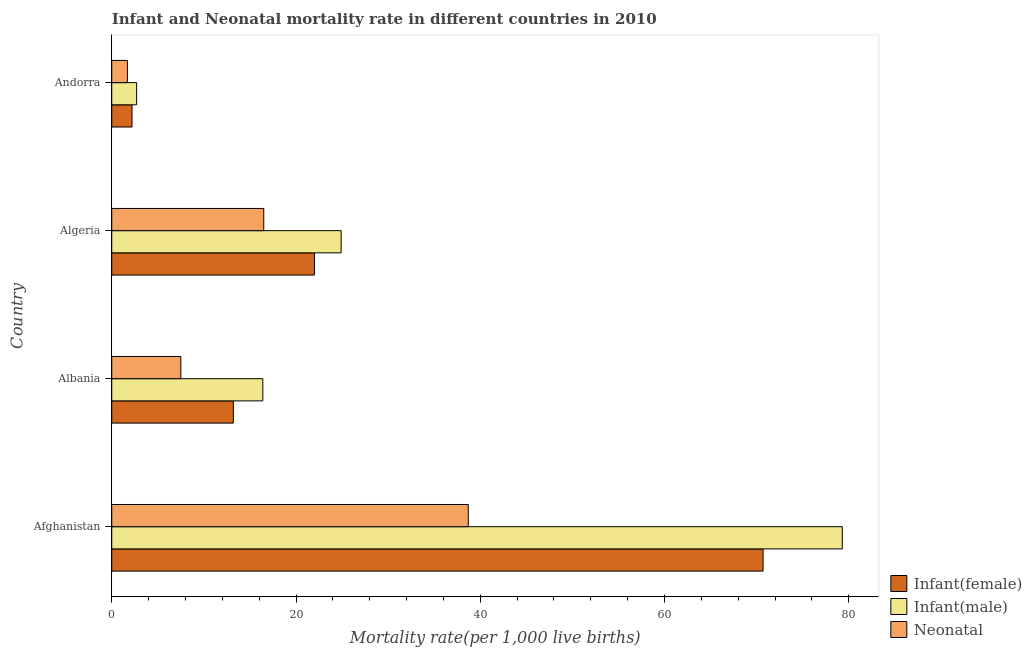How many different coloured bars are there?
Your response must be concise. 3. How many groups of bars are there?
Your answer should be compact. 4. Are the number of bars per tick equal to the number of legend labels?
Make the answer very short. Yes. Are the number of bars on each tick of the Y-axis equal?
Give a very brief answer. Yes. How many bars are there on the 4th tick from the bottom?
Give a very brief answer. 3. What is the label of the 1st group of bars from the top?
Ensure brevity in your answer.  Andorra. In how many cases, is the number of bars for a given country not equal to the number of legend labels?
Make the answer very short. 0. Across all countries, what is the maximum infant mortality rate(female)?
Provide a short and direct response. 70.7. In which country was the infant mortality rate(male) maximum?
Your response must be concise. Afghanistan. In which country was the infant mortality rate(male) minimum?
Keep it short and to the point. Andorra. What is the total infant mortality rate(male) in the graph?
Your response must be concise. 123.3. What is the difference between the infant mortality rate(female) in Afghanistan and that in Algeria?
Your answer should be compact. 48.7. What is the difference between the infant mortality rate(male) in Albania and the neonatal mortality rate in Algeria?
Give a very brief answer. -0.1. What is the average infant mortality rate(male) per country?
Offer a very short reply. 30.82. In how many countries, is the neonatal mortality rate greater than 68 ?
Your answer should be very brief. 0. What is the ratio of the infant mortality rate(male) in Albania to that in Algeria?
Give a very brief answer. 0.66. Is the infant mortality rate(female) in Afghanistan less than that in Andorra?
Offer a terse response. No. What is the difference between the highest and the second highest infant mortality rate(male)?
Make the answer very short. 54.4. What is the difference between the highest and the lowest infant mortality rate(male)?
Offer a very short reply. 76.6. What does the 3rd bar from the top in Albania represents?
Your answer should be compact. Infant(female). What does the 2nd bar from the bottom in Afghanistan represents?
Make the answer very short. Infant(male). How many bars are there?
Your response must be concise. 12. How many countries are there in the graph?
Offer a terse response. 4. What is the difference between two consecutive major ticks on the X-axis?
Provide a short and direct response. 20. Where does the legend appear in the graph?
Your answer should be very brief. Bottom right. How are the legend labels stacked?
Your answer should be compact. Vertical. What is the title of the graph?
Ensure brevity in your answer.  Infant and Neonatal mortality rate in different countries in 2010. What is the label or title of the X-axis?
Provide a succinct answer. Mortality rate(per 1,0 live births). What is the label or title of the Y-axis?
Make the answer very short. Country. What is the Mortality rate(per 1,000 live births) of Infant(female) in Afghanistan?
Provide a short and direct response. 70.7. What is the Mortality rate(per 1,000 live births) in Infant(male) in Afghanistan?
Ensure brevity in your answer.  79.3. What is the Mortality rate(per 1,000 live births) of Neonatal  in Afghanistan?
Your answer should be very brief. 38.7. What is the Mortality rate(per 1,000 live births) of Infant(female) in Algeria?
Offer a very short reply. 22. What is the Mortality rate(per 1,000 live births) in Infant(male) in Algeria?
Make the answer very short. 24.9. What is the Mortality rate(per 1,000 live births) in Infant(male) in Andorra?
Provide a succinct answer. 2.7. What is the Mortality rate(per 1,000 live births) in Neonatal  in Andorra?
Provide a succinct answer. 1.7. Across all countries, what is the maximum Mortality rate(per 1,000 live births) of Infant(female)?
Provide a succinct answer. 70.7. Across all countries, what is the maximum Mortality rate(per 1,000 live births) of Infant(male)?
Make the answer very short. 79.3. Across all countries, what is the maximum Mortality rate(per 1,000 live births) in Neonatal ?
Keep it short and to the point. 38.7. Across all countries, what is the minimum Mortality rate(per 1,000 live births) of Infant(female)?
Your response must be concise. 2.2. What is the total Mortality rate(per 1,000 live births) in Infant(female) in the graph?
Offer a terse response. 108.1. What is the total Mortality rate(per 1,000 live births) in Infant(male) in the graph?
Your response must be concise. 123.3. What is the total Mortality rate(per 1,000 live births) of Neonatal  in the graph?
Provide a short and direct response. 64.4. What is the difference between the Mortality rate(per 1,000 live births) in Infant(female) in Afghanistan and that in Albania?
Keep it short and to the point. 57.5. What is the difference between the Mortality rate(per 1,000 live births) in Infant(male) in Afghanistan and that in Albania?
Your response must be concise. 62.9. What is the difference between the Mortality rate(per 1,000 live births) of Neonatal  in Afghanistan and that in Albania?
Ensure brevity in your answer.  31.2. What is the difference between the Mortality rate(per 1,000 live births) in Infant(female) in Afghanistan and that in Algeria?
Ensure brevity in your answer.  48.7. What is the difference between the Mortality rate(per 1,000 live births) in Infant(male) in Afghanistan and that in Algeria?
Provide a short and direct response. 54.4. What is the difference between the Mortality rate(per 1,000 live births) of Neonatal  in Afghanistan and that in Algeria?
Provide a succinct answer. 22.2. What is the difference between the Mortality rate(per 1,000 live births) of Infant(female) in Afghanistan and that in Andorra?
Your answer should be very brief. 68.5. What is the difference between the Mortality rate(per 1,000 live births) of Infant(male) in Afghanistan and that in Andorra?
Give a very brief answer. 76.6. What is the difference between the Mortality rate(per 1,000 live births) of Neonatal  in Afghanistan and that in Andorra?
Give a very brief answer. 37. What is the difference between the Mortality rate(per 1,000 live births) in Infant(female) in Albania and that in Algeria?
Your response must be concise. -8.8. What is the difference between the Mortality rate(per 1,000 live births) of Infant(female) in Albania and that in Andorra?
Make the answer very short. 11. What is the difference between the Mortality rate(per 1,000 live births) of Infant(male) in Albania and that in Andorra?
Make the answer very short. 13.7. What is the difference between the Mortality rate(per 1,000 live births) of Neonatal  in Albania and that in Andorra?
Offer a very short reply. 5.8. What is the difference between the Mortality rate(per 1,000 live births) in Infant(female) in Algeria and that in Andorra?
Provide a succinct answer. 19.8. What is the difference between the Mortality rate(per 1,000 live births) in Infant(female) in Afghanistan and the Mortality rate(per 1,000 live births) in Infant(male) in Albania?
Your answer should be compact. 54.3. What is the difference between the Mortality rate(per 1,000 live births) of Infant(female) in Afghanistan and the Mortality rate(per 1,000 live births) of Neonatal  in Albania?
Your answer should be compact. 63.2. What is the difference between the Mortality rate(per 1,000 live births) in Infant(male) in Afghanistan and the Mortality rate(per 1,000 live births) in Neonatal  in Albania?
Provide a succinct answer. 71.8. What is the difference between the Mortality rate(per 1,000 live births) of Infant(female) in Afghanistan and the Mortality rate(per 1,000 live births) of Infant(male) in Algeria?
Your answer should be very brief. 45.8. What is the difference between the Mortality rate(per 1,000 live births) in Infant(female) in Afghanistan and the Mortality rate(per 1,000 live births) in Neonatal  in Algeria?
Your answer should be very brief. 54.2. What is the difference between the Mortality rate(per 1,000 live births) in Infant(male) in Afghanistan and the Mortality rate(per 1,000 live births) in Neonatal  in Algeria?
Your response must be concise. 62.8. What is the difference between the Mortality rate(per 1,000 live births) in Infant(female) in Afghanistan and the Mortality rate(per 1,000 live births) in Infant(male) in Andorra?
Ensure brevity in your answer.  68. What is the difference between the Mortality rate(per 1,000 live births) in Infant(male) in Afghanistan and the Mortality rate(per 1,000 live births) in Neonatal  in Andorra?
Offer a very short reply. 77.6. What is the difference between the Mortality rate(per 1,000 live births) in Infant(female) in Albania and the Mortality rate(per 1,000 live births) in Neonatal  in Algeria?
Your answer should be compact. -3.3. What is the difference between the Mortality rate(per 1,000 live births) of Infant(male) in Albania and the Mortality rate(per 1,000 live births) of Neonatal  in Algeria?
Ensure brevity in your answer.  -0.1. What is the difference between the Mortality rate(per 1,000 live births) in Infant(female) in Albania and the Mortality rate(per 1,000 live births) in Infant(male) in Andorra?
Your answer should be compact. 10.5. What is the difference between the Mortality rate(per 1,000 live births) in Infant(male) in Albania and the Mortality rate(per 1,000 live births) in Neonatal  in Andorra?
Ensure brevity in your answer.  14.7. What is the difference between the Mortality rate(per 1,000 live births) of Infant(female) in Algeria and the Mortality rate(per 1,000 live births) of Infant(male) in Andorra?
Your answer should be very brief. 19.3. What is the difference between the Mortality rate(per 1,000 live births) of Infant(female) in Algeria and the Mortality rate(per 1,000 live births) of Neonatal  in Andorra?
Provide a short and direct response. 20.3. What is the difference between the Mortality rate(per 1,000 live births) in Infant(male) in Algeria and the Mortality rate(per 1,000 live births) in Neonatal  in Andorra?
Your response must be concise. 23.2. What is the average Mortality rate(per 1,000 live births) of Infant(female) per country?
Provide a succinct answer. 27.02. What is the average Mortality rate(per 1,000 live births) of Infant(male) per country?
Offer a very short reply. 30.82. What is the average Mortality rate(per 1,000 live births) of Neonatal  per country?
Your answer should be very brief. 16.1. What is the difference between the Mortality rate(per 1,000 live births) of Infant(female) and Mortality rate(per 1,000 live births) of Infant(male) in Afghanistan?
Provide a succinct answer. -8.6. What is the difference between the Mortality rate(per 1,000 live births) in Infant(female) and Mortality rate(per 1,000 live births) in Neonatal  in Afghanistan?
Offer a very short reply. 32. What is the difference between the Mortality rate(per 1,000 live births) of Infant(male) and Mortality rate(per 1,000 live births) of Neonatal  in Afghanistan?
Provide a short and direct response. 40.6. What is the difference between the Mortality rate(per 1,000 live births) in Infant(male) and Mortality rate(per 1,000 live births) in Neonatal  in Albania?
Make the answer very short. 8.9. What is the difference between the Mortality rate(per 1,000 live births) in Infant(female) and Mortality rate(per 1,000 live births) in Neonatal  in Algeria?
Your answer should be compact. 5.5. What is the difference between the Mortality rate(per 1,000 live births) of Infant(male) and Mortality rate(per 1,000 live births) of Neonatal  in Algeria?
Give a very brief answer. 8.4. What is the difference between the Mortality rate(per 1,000 live births) of Infant(male) and Mortality rate(per 1,000 live births) of Neonatal  in Andorra?
Keep it short and to the point. 1. What is the ratio of the Mortality rate(per 1,000 live births) of Infant(female) in Afghanistan to that in Albania?
Your response must be concise. 5.36. What is the ratio of the Mortality rate(per 1,000 live births) in Infant(male) in Afghanistan to that in Albania?
Your answer should be very brief. 4.84. What is the ratio of the Mortality rate(per 1,000 live births) of Neonatal  in Afghanistan to that in Albania?
Provide a short and direct response. 5.16. What is the ratio of the Mortality rate(per 1,000 live births) of Infant(female) in Afghanistan to that in Algeria?
Keep it short and to the point. 3.21. What is the ratio of the Mortality rate(per 1,000 live births) of Infant(male) in Afghanistan to that in Algeria?
Offer a terse response. 3.18. What is the ratio of the Mortality rate(per 1,000 live births) of Neonatal  in Afghanistan to that in Algeria?
Ensure brevity in your answer.  2.35. What is the ratio of the Mortality rate(per 1,000 live births) of Infant(female) in Afghanistan to that in Andorra?
Keep it short and to the point. 32.14. What is the ratio of the Mortality rate(per 1,000 live births) of Infant(male) in Afghanistan to that in Andorra?
Your response must be concise. 29.37. What is the ratio of the Mortality rate(per 1,000 live births) in Neonatal  in Afghanistan to that in Andorra?
Provide a succinct answer. 22.76. What is the ratio of the Mortality rate(per 1,000 live births) of Infant(male) in Albania to that in Algeria?
Your response must be concise. 0.66. What is the ratio of the Mortality rate(per 1,000 live births) in Neonatal  in Albania to that in Algeria?
Make the answer very short. 0.45. What is the ratio of the Mortality rate(per 1,000 live births) of Infant(male) in Albania to that in Andorra?
Offer a very short reply. 6.07. What is the ratio of the Mortality rate(per 1,000 live births) of Neonatal  in Albania to that in Andorra?
Offer a terse response. 4.41. What is the ratio of the Mortality rate(per 1,000 live births) of Infant(female) in Algeria to that in Andorra?
Keep it short and to the point. 10. What is the ratio of the Mortality rate(per 1,000 live births) in Infant(male) in Algeria to that in Andorra?
Give a very brief answer. 9.22. What is the ratio of the Mortality rate(per 1,000 live births) in Neonatal  in Algeria to that in Andorra?
Provide a succinct answer. 9.71. What is the difference between the highest and the second highest Mortality rate(per 1,000 live births) of Infant(female)?
Give a very brief answer. 48.7. What is the difference between the highest and the second highest Mortality rate(per 1,000 live births) of Infant(male)?
Give a very brief answer. 54.4. What is the difference between the highest and the lowest Mortality rate(per 1,000 live births) in Infant(female)?
Your answer should be compact. 68.5. What is the difference between the highest and the lowest Mortality rate(per 1,000 live births) of Infant(male)?
Your answer should be very brief. 76.6. What is the difference between the highest and the lowest Mortality rate(per 1,000 live births) in Neonatal ?
Give a very brief answer. 37. 